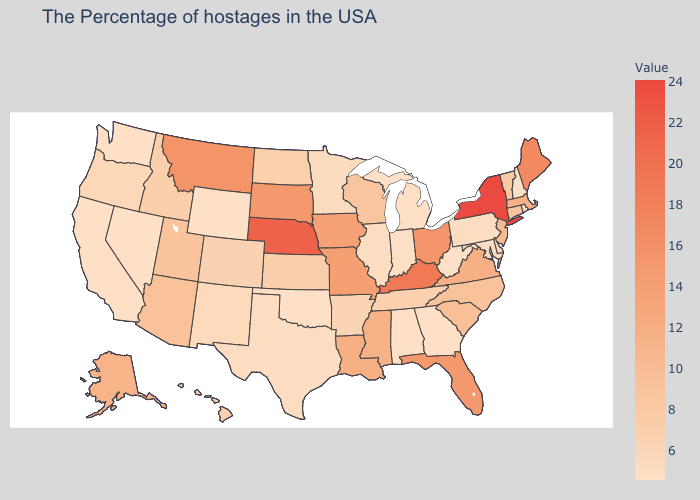Does the map have missing data?
Quick response, please. No. Does Missouri have a higher value than Utah?
Keep it brief. Yes. Does the map have missing data?
Short answer required. No. Among the states that border Oklahoma , does Colorado have the lowest value?
Short answer required. No. Does Kentucky have the highest value in the USA?
Keep it brief. No. 